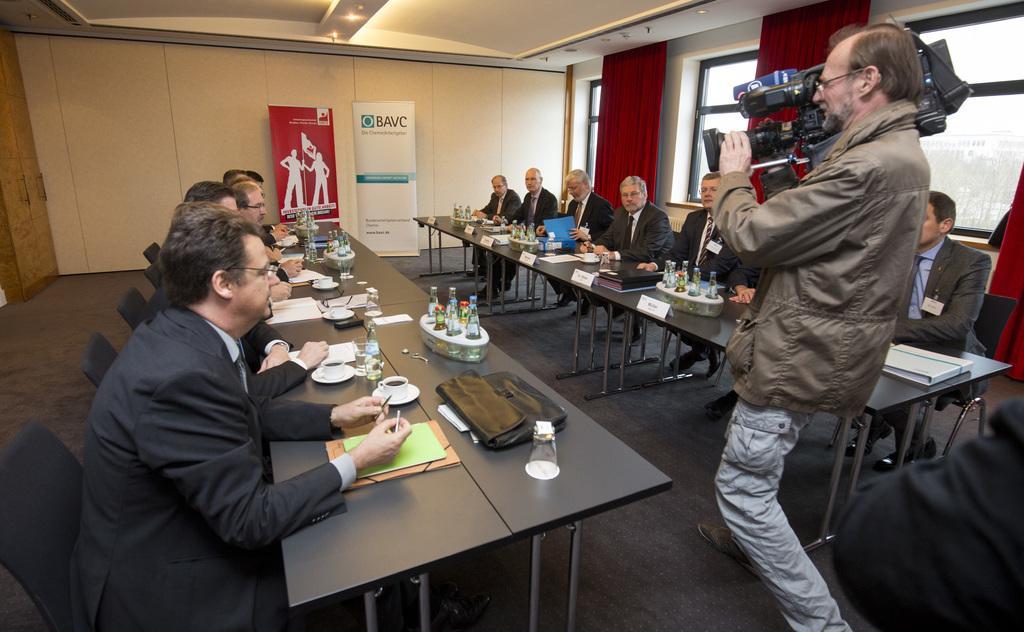Could you give a brief overview of what you see in this image? In this Image I see number of people who are sitting on the chairs and there are tables in front of them and I see many things on it. I can also see a man who is standing over here and holding a video camera, In the background I see the wall, banners, windows and the curtains. 